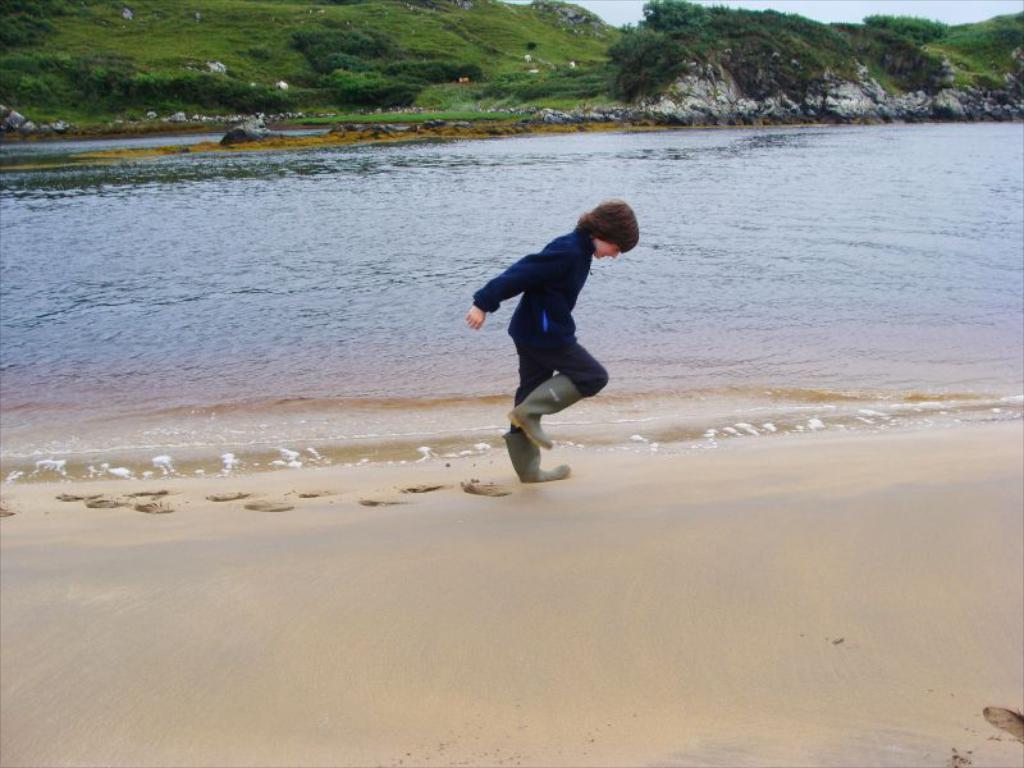Can you describe this image briefly? Here we can see a boy and water. Background there is a grass and plants. 